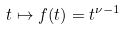<formula> <loc_0><loc_0><loc_500><loc_500>t \mapsto f ( t ) = t ^ { \nu - 1 }</formula> 